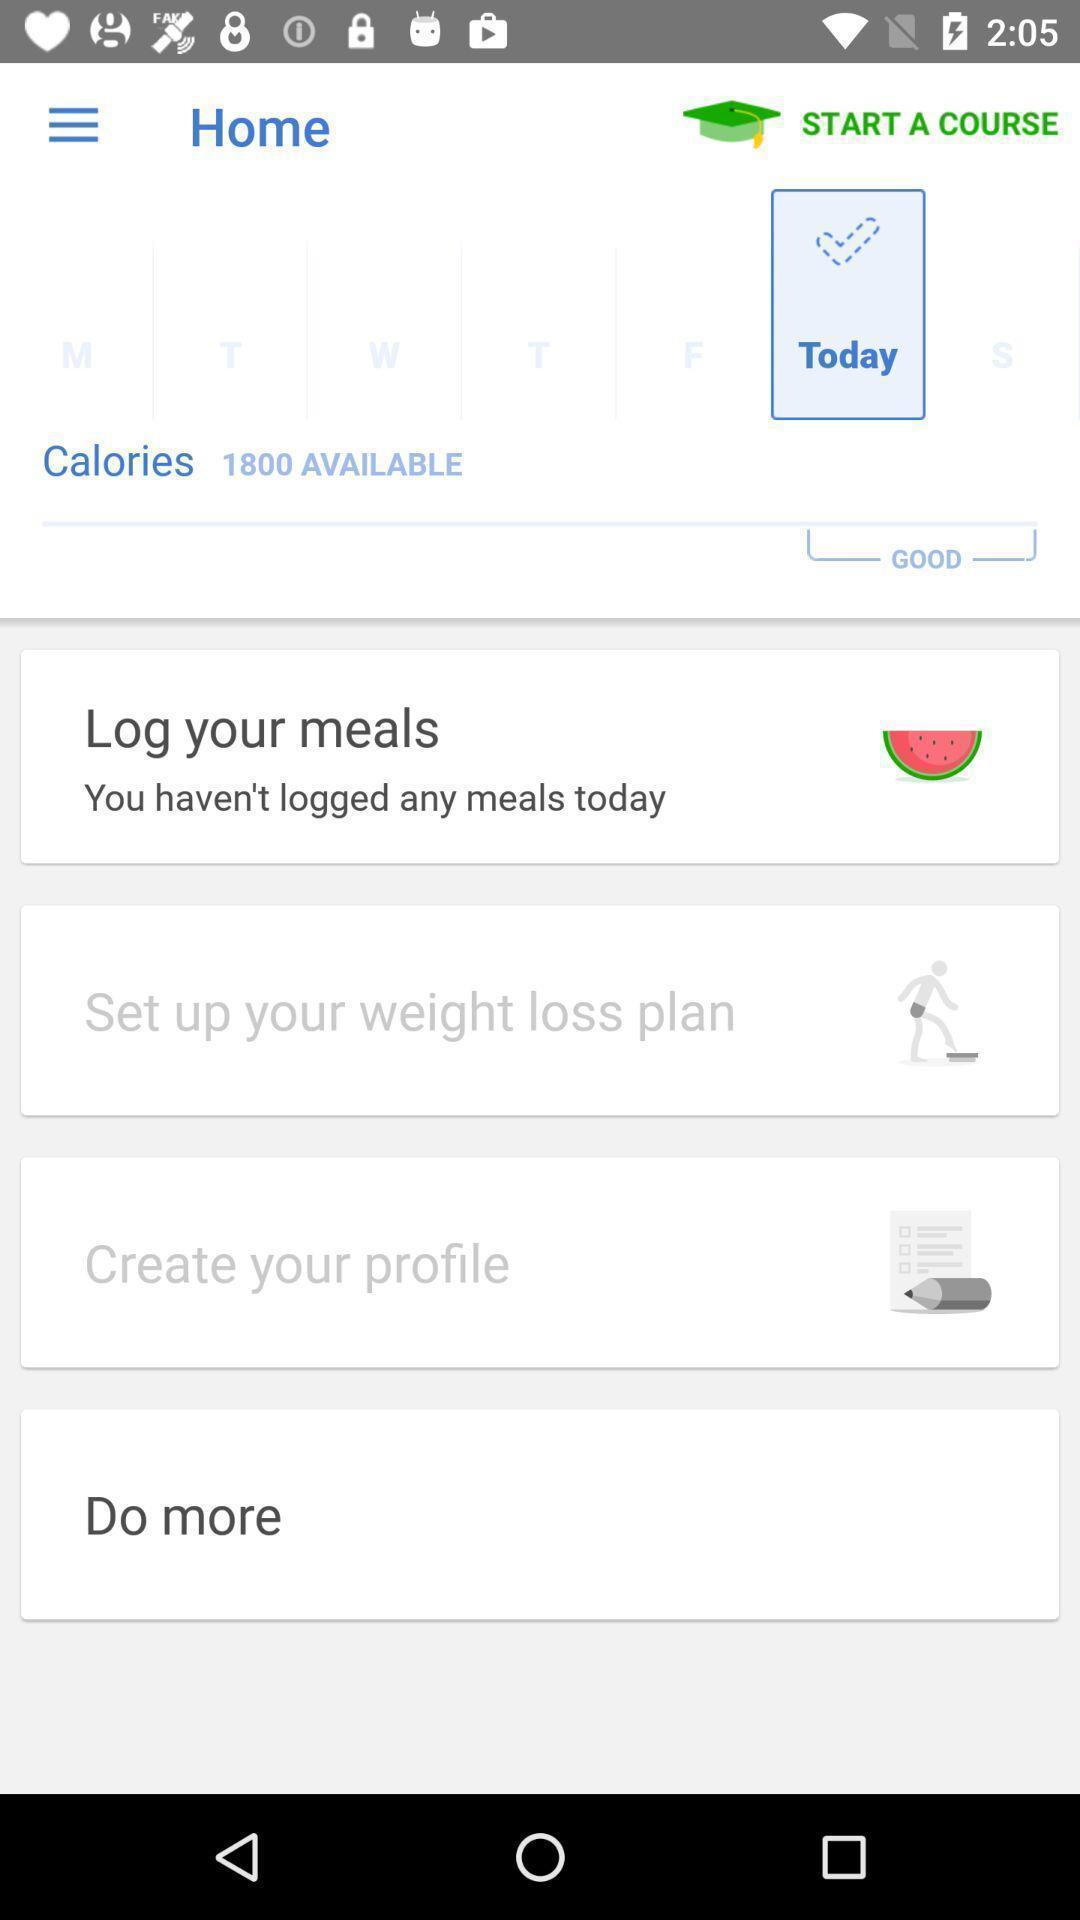What is the overall content of this screenshot? Page shows details about health application. 